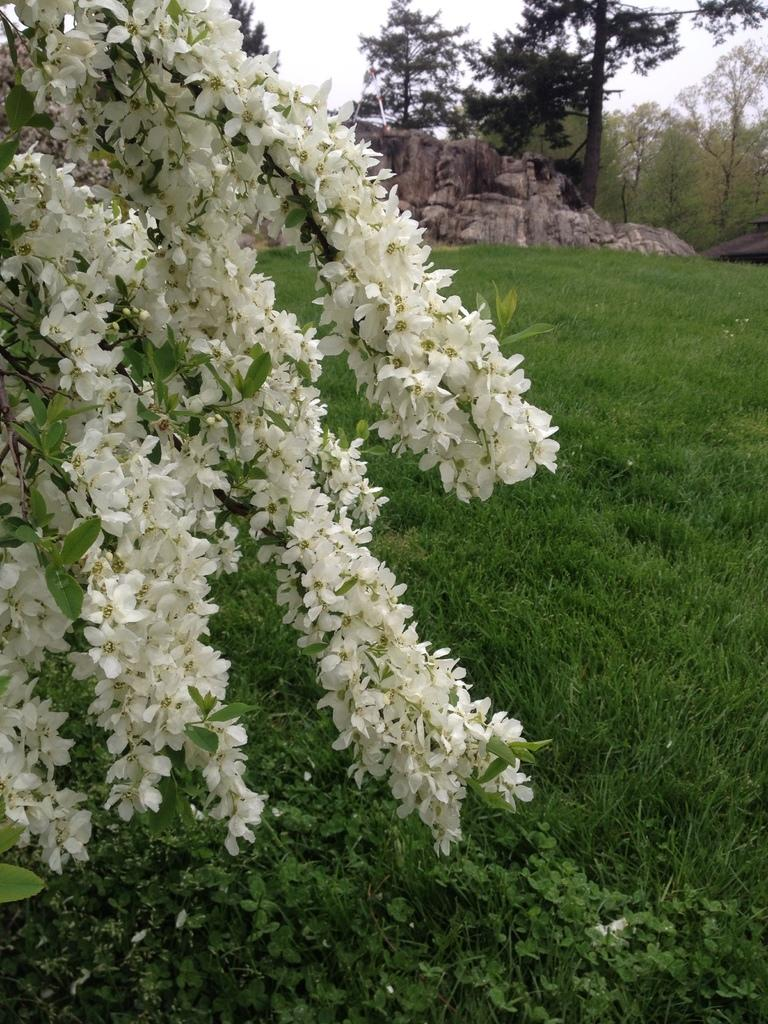What type of plants can be seen in the image? There are flowers in the image. What color are the flowers? The flowers are white. What is covering the ground in the image? The ground is covered in greenery. What can be seen in the background of the image? There are rocks and trees in the background of the image. What type of skirt is hanging on the tree in the image? There is no skirt present in the image; it features flowers, greenery, rocks, and trees. 